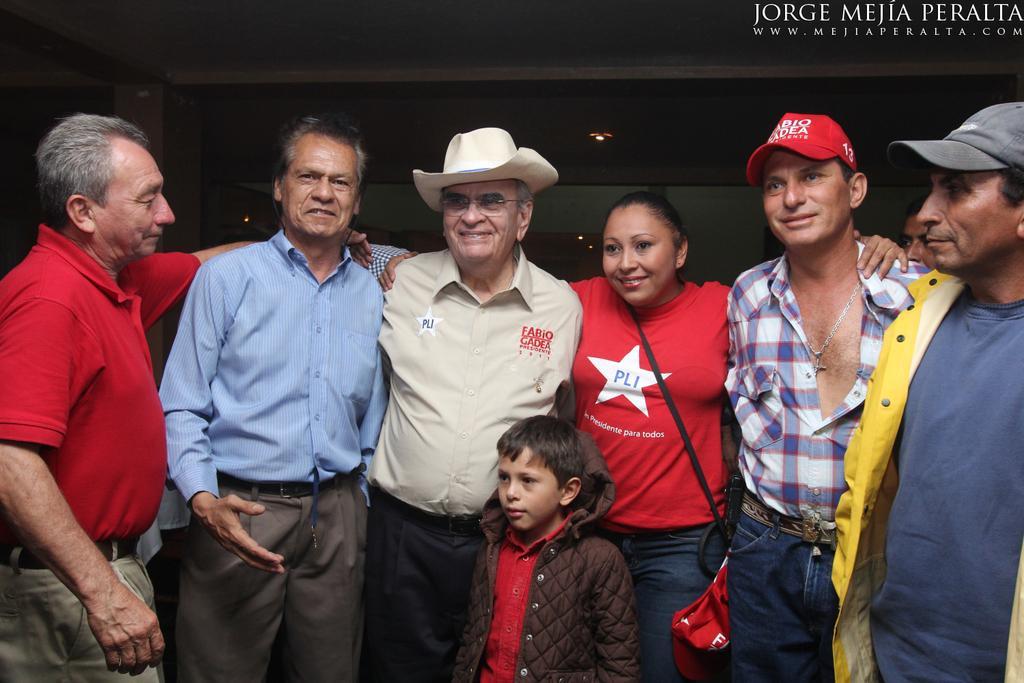In one or two sentences, can you explain what this image depicts? In this image in the center there are some people who are standing and one person is wearing a bag, and there is one boy. In the background there is a wall and also we could see some lights, at the top there is ceiling. 